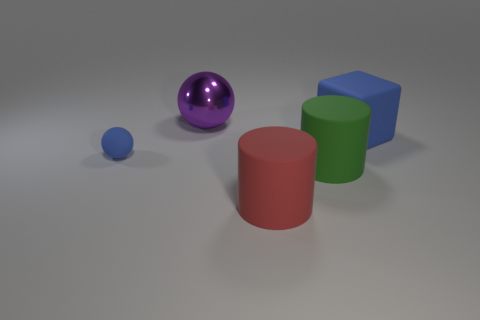Add 2 large cyan rubber objects. How many objects exist? 7 Subtract all balls. How many objects are left? 3 Add 2 brown metallic blocks. How many brown metallic blocks exist? 2 Subtract 0 green cubes. How many objects are left? 5 Subtract all gray cylinders. Subtract all large purple objects. How many objects are left? 4 Add 4 tiny matte balls. How many tiny matte balls are left? 5 